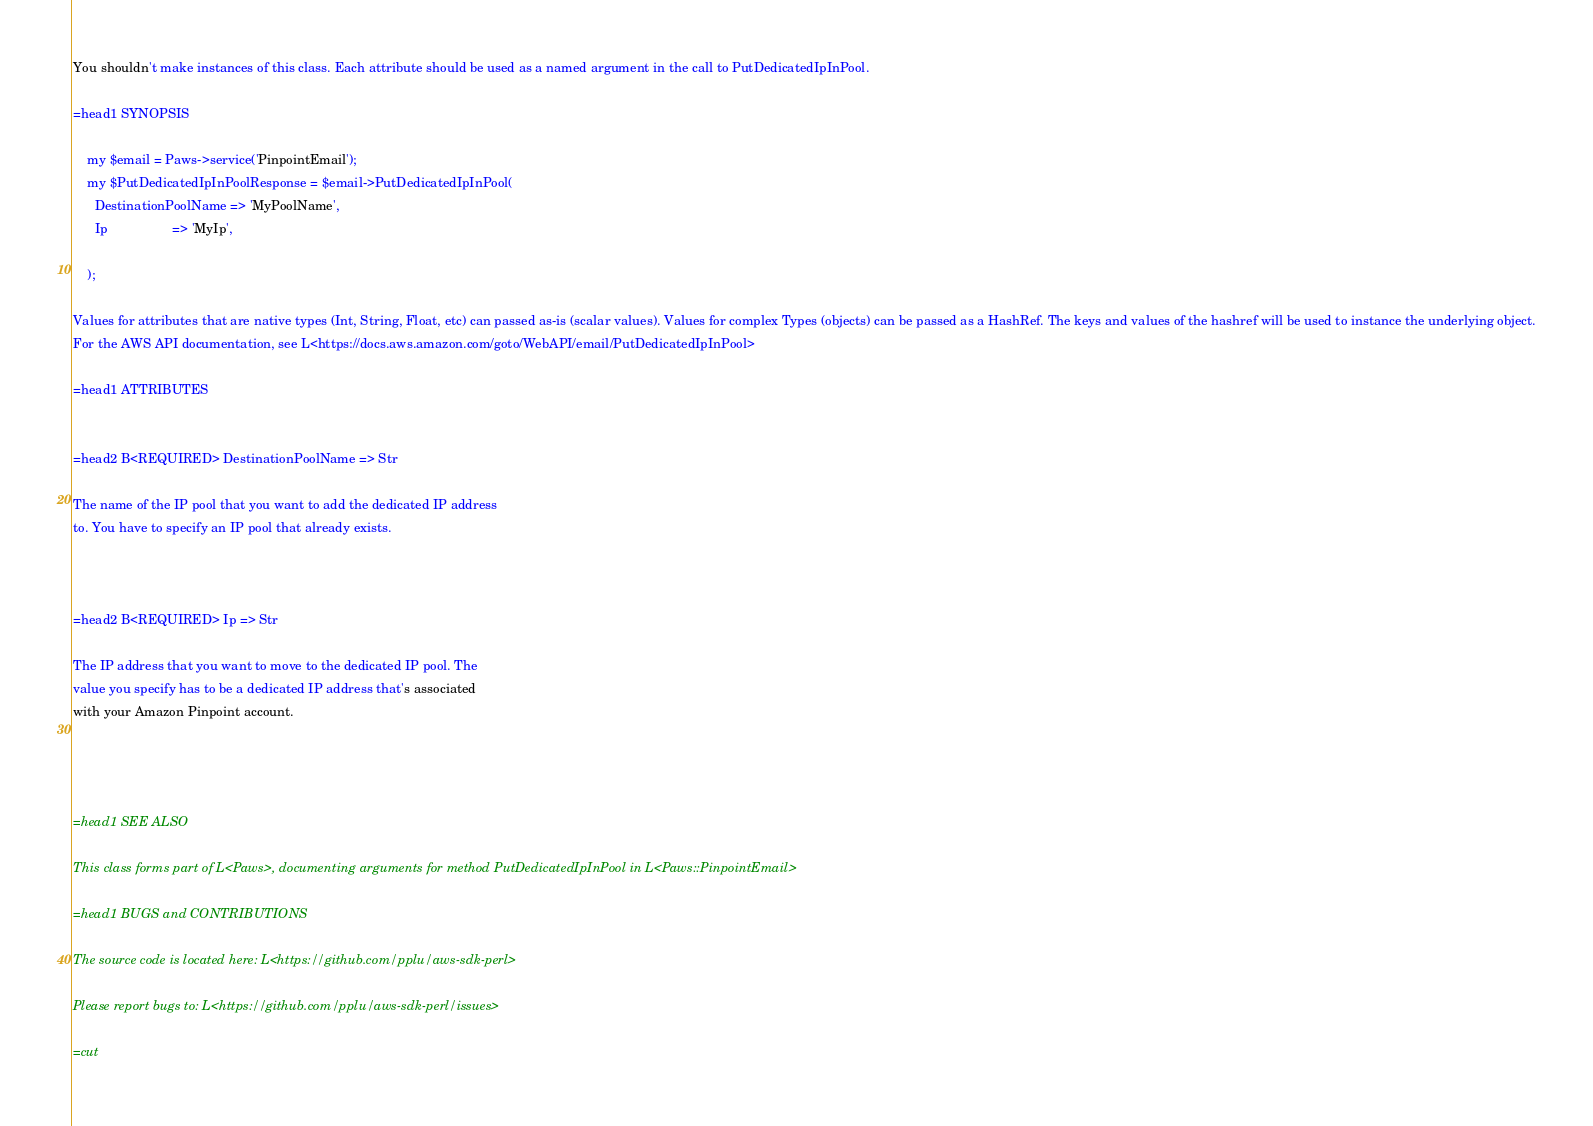<code> <loc_0><loc_0><loc_500><loc_500><_Perl_>You shouldn't make instances of this class. Each attribute should be used as a named argument in the call to PutDedicatedIpInPool.

=head1 SYNOPSIS

    my $email = Paws->service('PinpointEmail');
    my $PutDedicatedIpInPoolResponse = $email->PutDedicatedIpInPool(
      DestinationPoolName => 'MyPoolName',
      Ip                  => 'MyIp',

    );

Values for attributes that are native types (Int, String, Float, etc) can passed as-is (scalar values). Values for complex Types (objects) can be passed as a HashRef. The keys and values of the hashref will be used to instance the underlying object.
For the AWS API documentation, see L<https://docs.aws.amazon.com/goto/WebAPI/email/PutDedicatedIpInPool>

=head1 ATTRIBUTES


=head2 B<REQUIRED> DestinationPoolName => Str

The name of the IP pool that you want to add the dedicated IP address
to. You have to specify an IP pool that already exists.



=head2 B<REQUIRED> Ip => Str

The IP address that you want to move to the dedicated IP pool. The
value you specify has to be a dedicated IP address that's associated
with your Amazon Pinpoint account.




=head1 SEE ALSO

This class forms part of L<Paws>, documenting arguments for method PutDedicatedIpInPool in L<Paws::PinpointEmail>

=head1 BUGS and CONTRIBUTIONS

The source code is located here: L<https://github.com/pplu/aws-sdk-perl>

Please report bugs to: L<https://github.com/pplu/aws-sdk-perl/issues>

=cut

</code> 